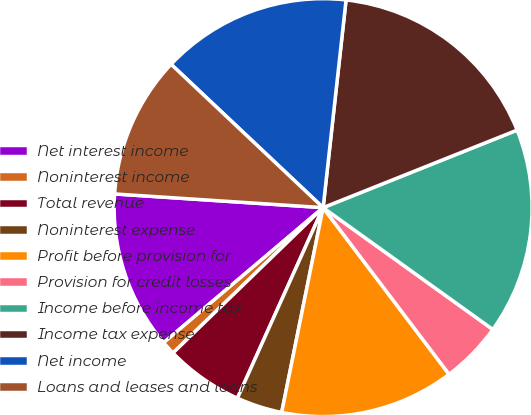<chart> <loc_0><loc_0><loc_500><loc_500><pie_chart><fcel>Net interest income<fcel>Noninterest income<fcel>Total revenue<fcel>Noninterest expense<fcel>Profit before provision for<fcel>Provision for credit losses<fcel>Income before income tax<fcel>Income tax expense<fcel>Net income<fcel>Loans and leases and loans<nl><fcel>12.23%<fcel>1.06%<fcel>6.03%<fcel>3.55%<fcel>13.48%<fcel>4.79%<fcel>15.96%<fcel>17.2%<fcel>14.72%<fcel>10.99%<nl></chart> 